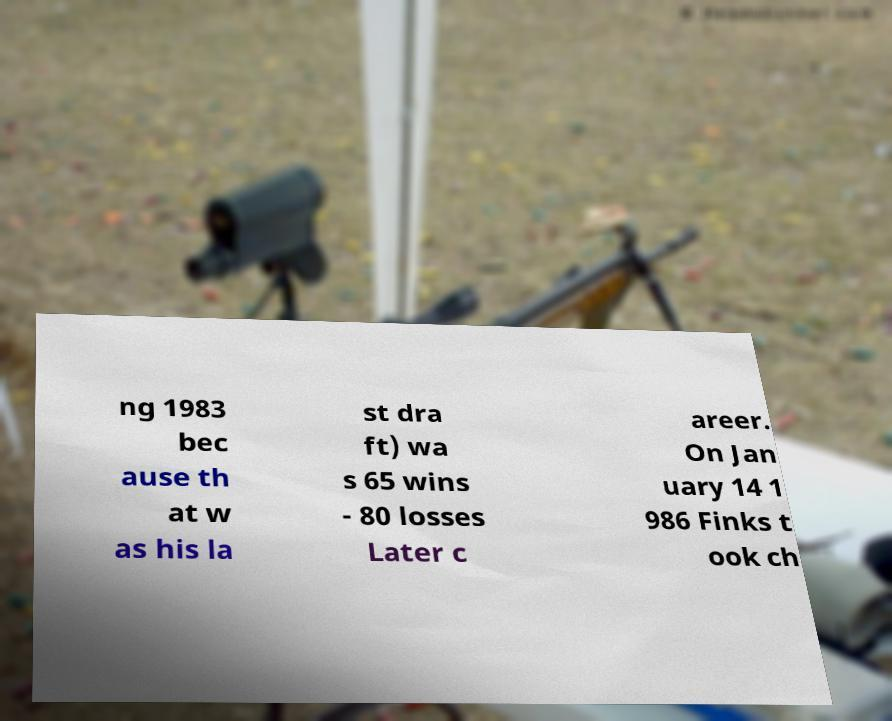What messages or text are displayed in this image? I need them in a readable, typed format. ng 1983 bec ause th at w as his la st dra ft) wa s 65 wins - 80 losses Later c areer. On Jan uary 14 1 986 Finks t ook ch 